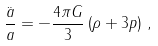Convert formula to latex. <formula><loc_0><loc_0><loc_500><loc_500>\frac { \ddot { a } } { a } = - \frac { 4 \pi G } { 3 } \left ( \rho + 3 p \right ) \, ,</formula> 